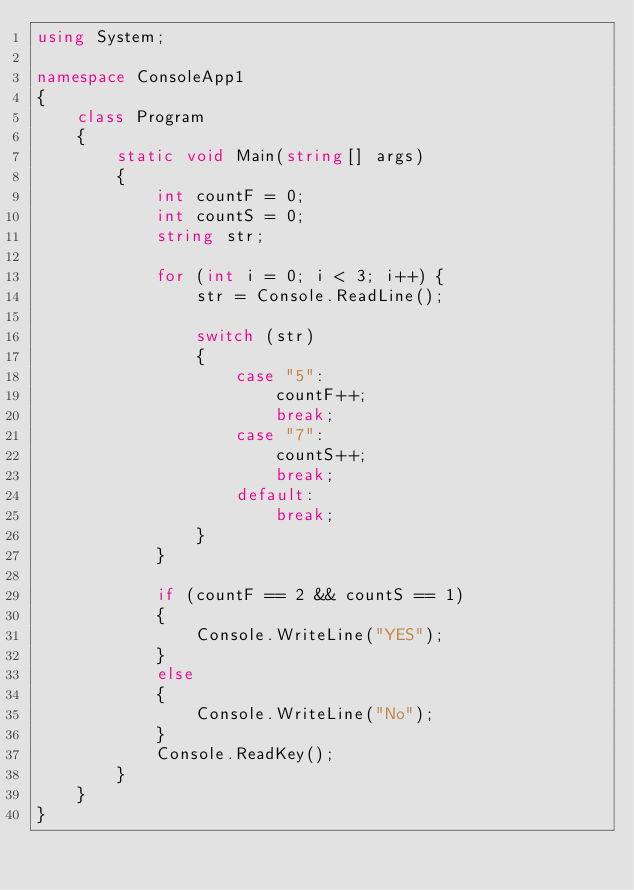Convert code to text. <code><loc_0><loc_0><loc_500><loc_500><_C#_>using System;

namespace ConsoleApp1
{
    class Program
    {
        static void Main(string[] args)
        {
            int countF = 0;
            int countS = 0;
            string str;

            for (int i = 0; i < 3; i++) {
                str = Console.ReadLine();

                switch (str) 
                {
                    case "5":
                        countF++;
                        break;
                    case "7":
                        countS++;
                        break;
                    default:
                        break;
                }
            }

            if (countF == 2 && countS == 1)
            {
                Console.WriteLine("YES");
            }
            else 
            {
                Console.WriteLine("No");
            }
            Console.ReadKey();
        }
    }
}
</code> 